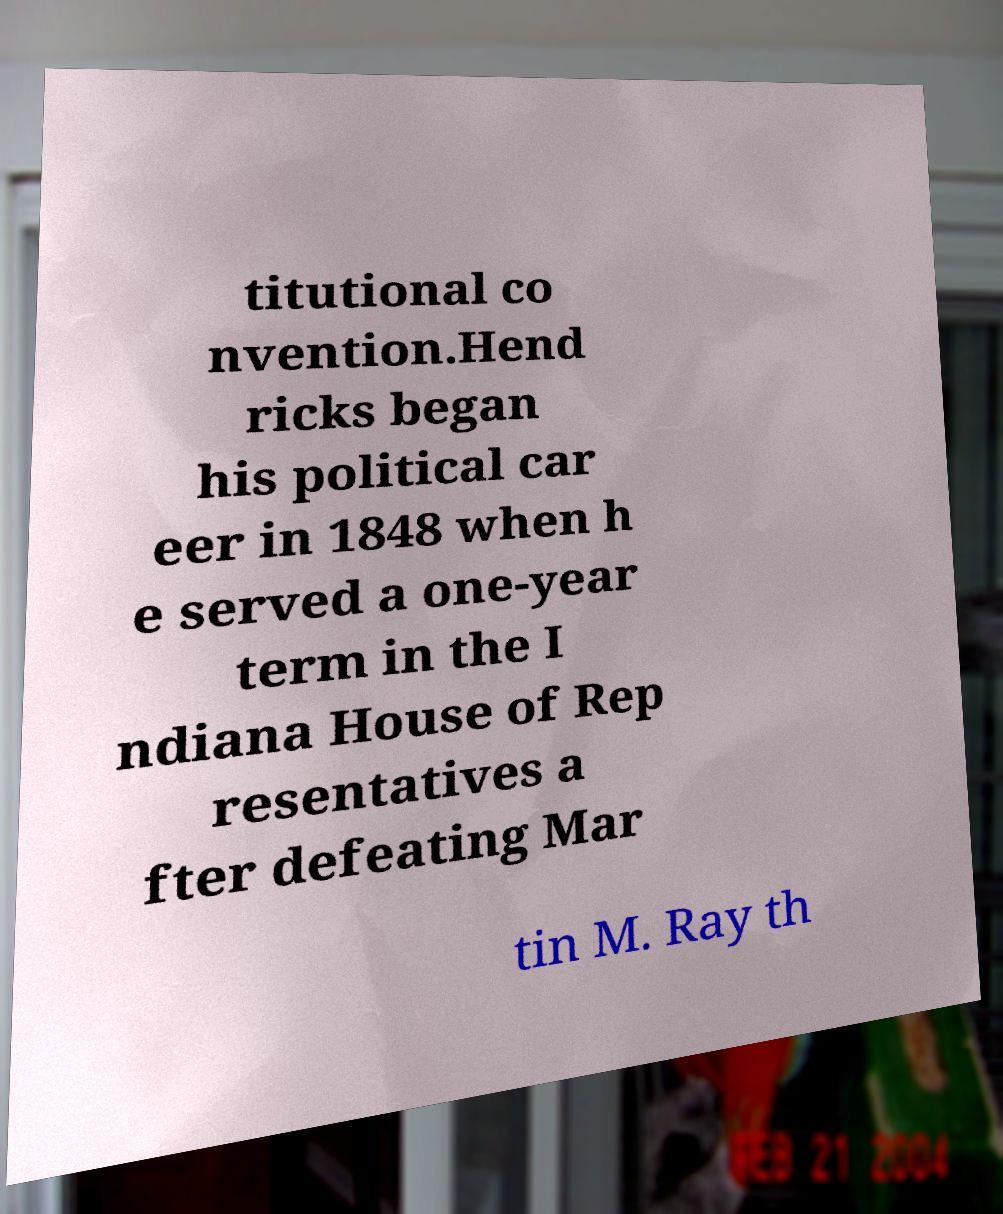Could you assist in decoding the text presented in this image and type it out clearly? titutional co nvention.Hend ricks began his political car eer in 1848 when h e served a one-year term in the I ndiana House of Rep resentatives a fter defeating Mar tin M. Ray th 